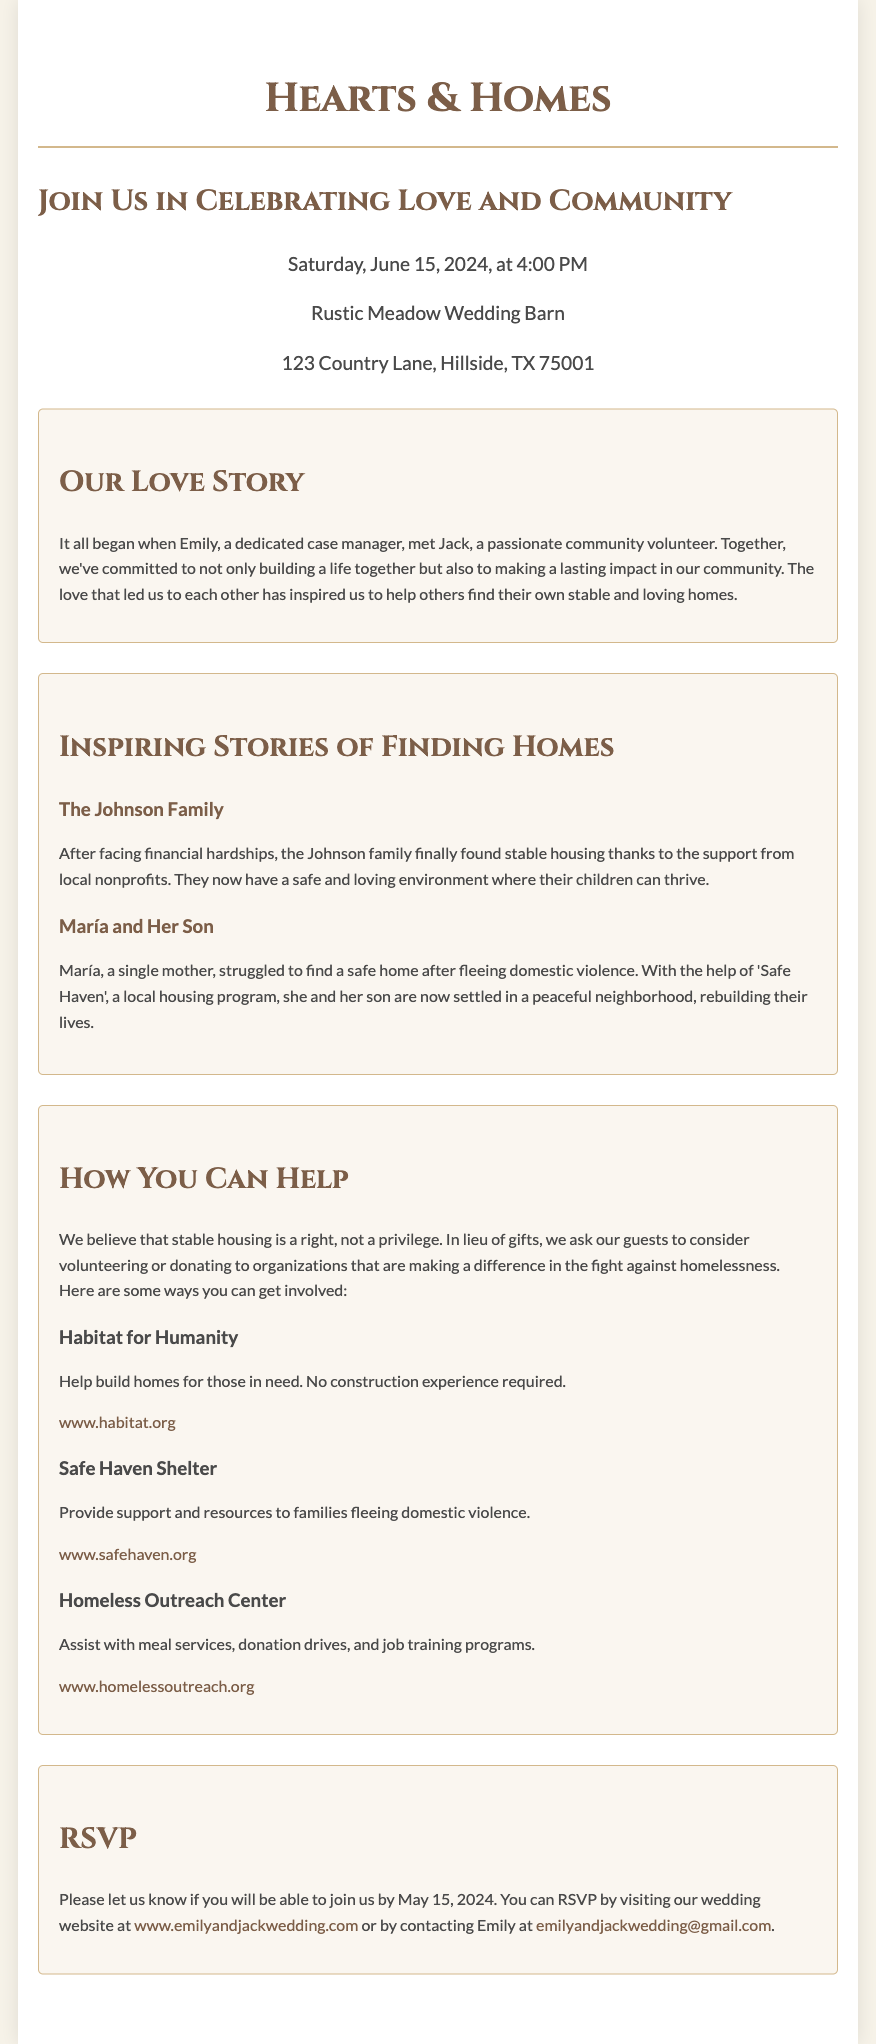What is the date of the wedding? The wedding will take place on Saturday, June 15, 2024.
Answer: June 15, 2024 Where is the wedding venue located? The wedding will be held at Rustic Meadow Wedding Barn, 123 Country Lane, Hillside, TX 75001.
Answer: Rustic Meadow Wedding Barn Who are the couple getting married? The couple getting married are Emily and Jack.
Answer: Emily and Jack What is the main theme of this wedding invitation? The main theme of the invitation is focused on social change and stable housing.
Answer: Social change What is the deadline for RSVPing? Guests are asked to RSVP by May 15, 2024.
Answer: May 15, 2024 Which organization helps build homes for those in need? Habitat for Humanity is mentioned as an organization that helps build homes.
Answer: Habitat for Humanity What unique aspect does this wedding invitation highlight? The invitation juxtaposes a love story with inspiring stories of families finding stable housing.
Answer: Inspiring stories of families finding stable housing What type of support does Safe Haven Shelter provide? Safe Haven Shelter provides support and resources for families fleeing domestic violence.
Answer: Support for families fleeing domestic violence 